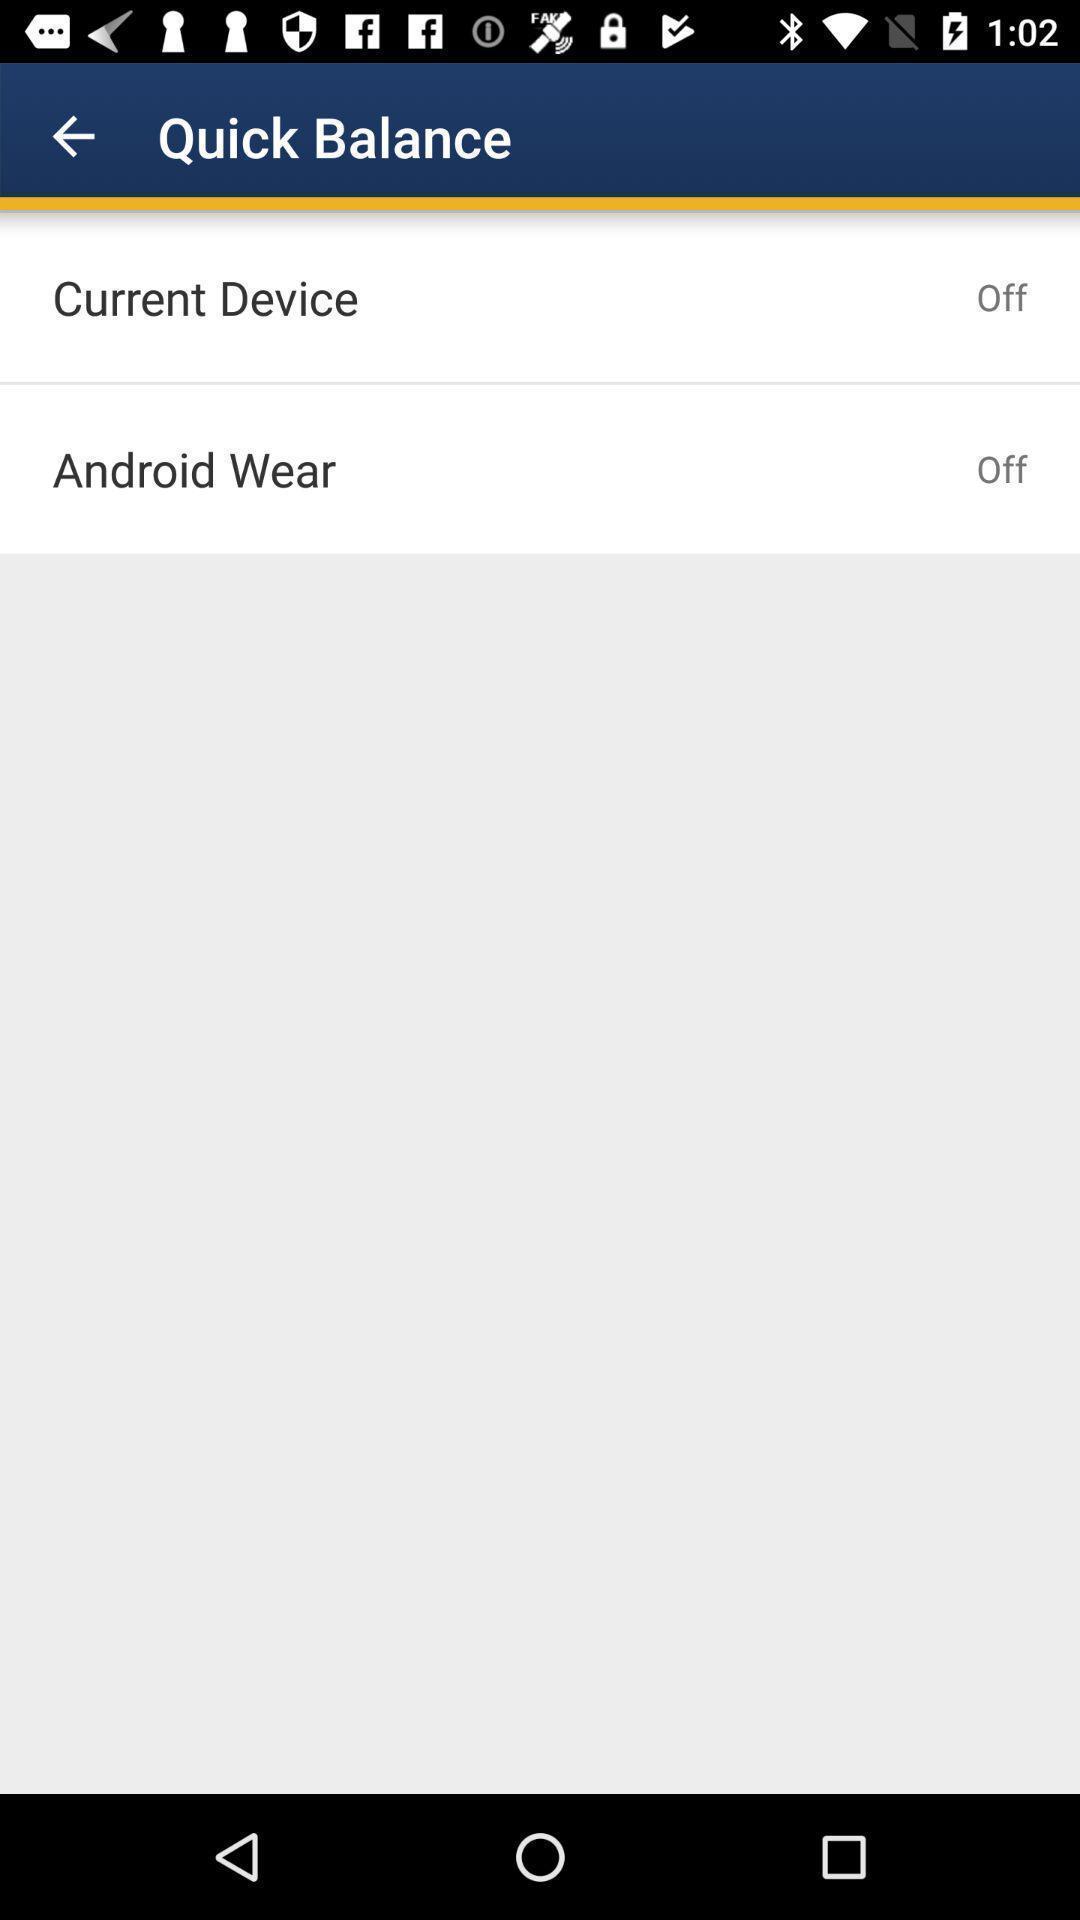Provide a textual representation of this image. Page showing few options in banking app. 